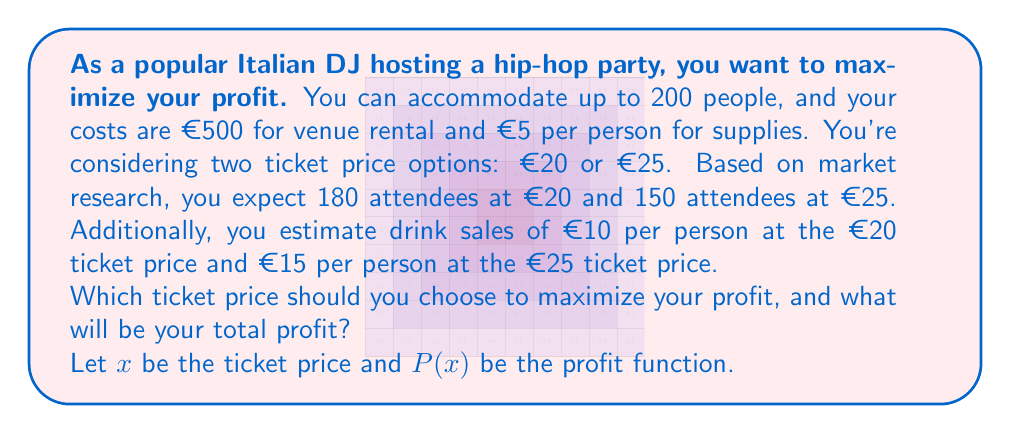Help me with this question. To solve this optimization problem, we need to calculate the profit for each ticket price option and compare them:

1. For €20 ticket price:
   - Expected attendance: 180 people
   - Revenue from tickets: $180 \times €20 = €3600$
   - Revenue from drinks: $180 \times €10 = €1800$
   - Total revenue: $€3600 + €1800 = €5400$
   - Costs: $€500 + (180 \times €5) = €1400$
   - Profit: $P(20) = €5400 - €1400 = €4000$

2. For €25 ticket price:
   - Expected attendance: 150 people
   - Revenue from tickets: $150 \times €25 = €3750$
   - Revenue from drinks: $150 \times €15 = €2250$
   - Total revenue: $€3750 + €2250 = €6000$
   - Costs: $€500 + (150 \times €5) = €1250$
   - Profit: $P(25) = €6000 - €1250 = €4750$

The profit function can be expressed as:

$$P(x) = \begin{cases}
4000 & \text{if } x = 20 \\
4750 & \text{if } x = 25
\end{cases}$$

Comparing the two profit values, we can see that $P(25) > P(20)$, so the €25 ticket price yields a higher profit.
Answer: Choose the €25 ticket price to maximize profit. The total profit will be €4750. 